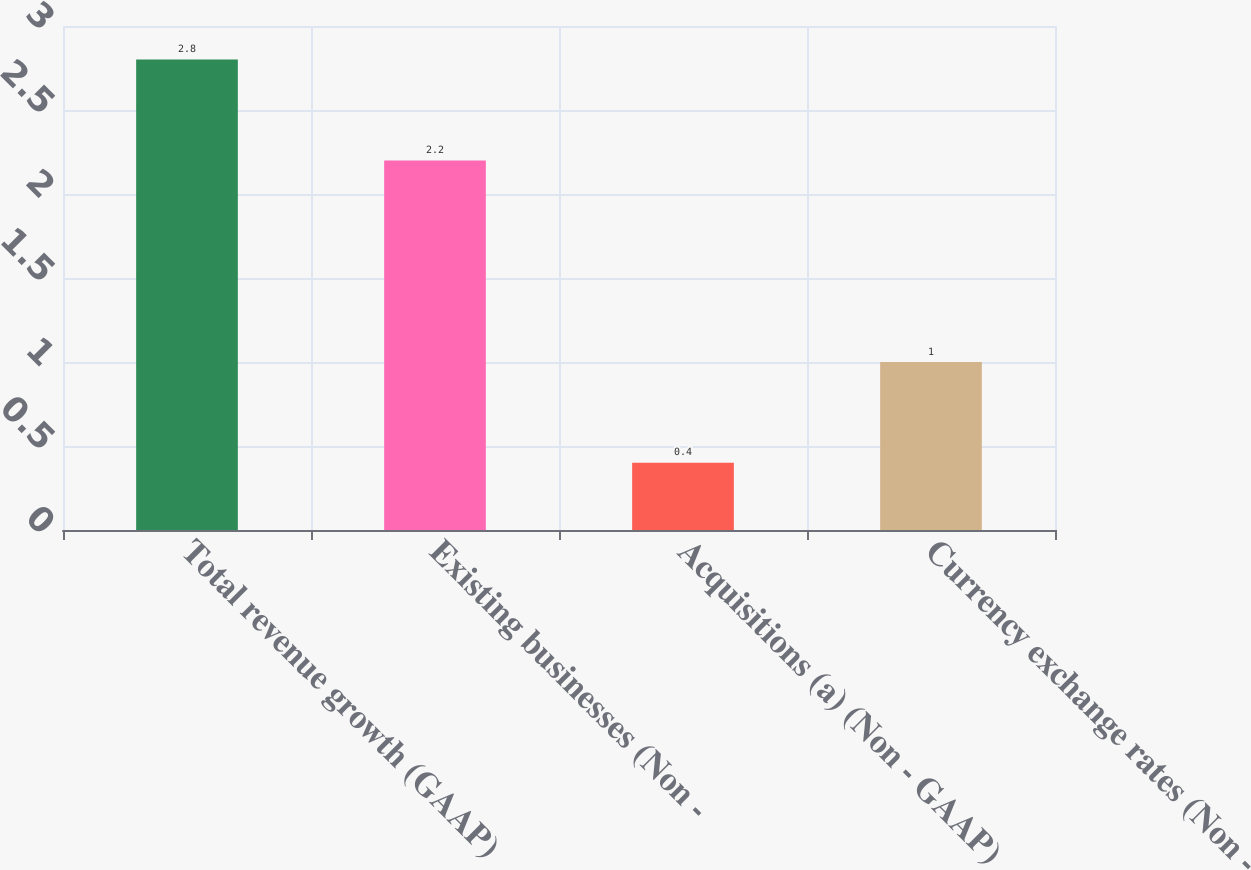<chart> <loc_0><loc_0><loc_500><loc_500><bar_chart><fcel>Total revenue growth (GAAP)<fcel>Existing businesses (Non -<fcel>Acquisitions (a) (Non - GAAP)<fcel>Currency exchange rates (Non -<nl><fcel>2.8<fcel>2.2<fcel>0.4<fcel>1<nl></chart> 